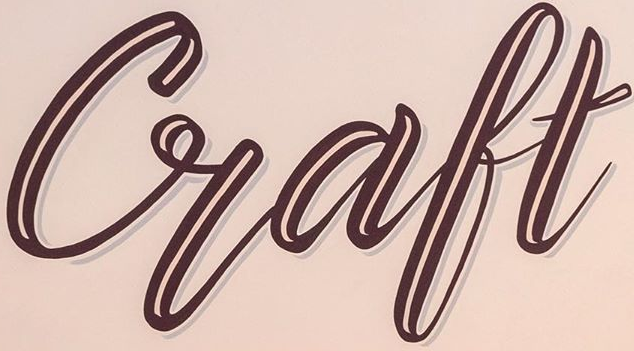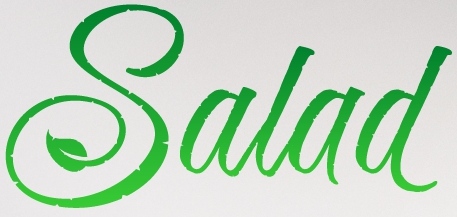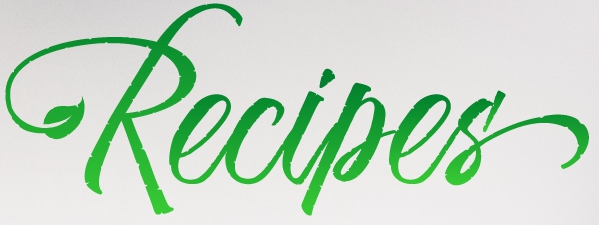What text is displayed in these images sequentially, separated by a semicolon? Craft; Salad; Recipes' 